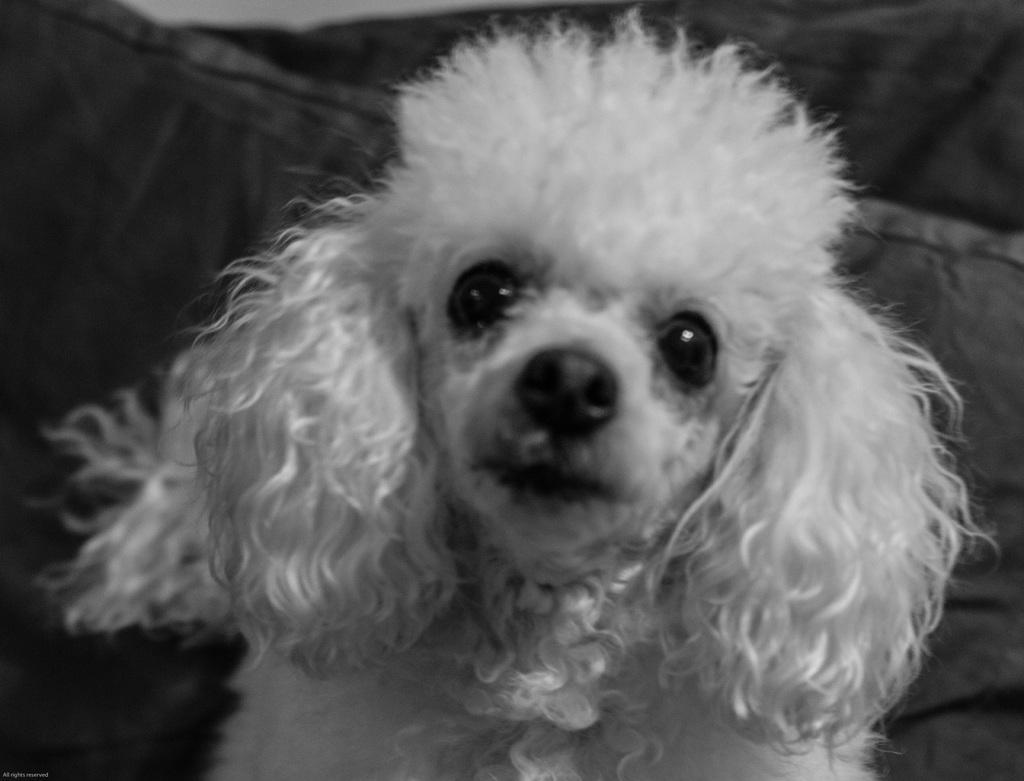Could you give a brief overview of what you see in this image? It is the black and white image in which we can see there is a puppy in the middle. In the background it looks like a cushion. 